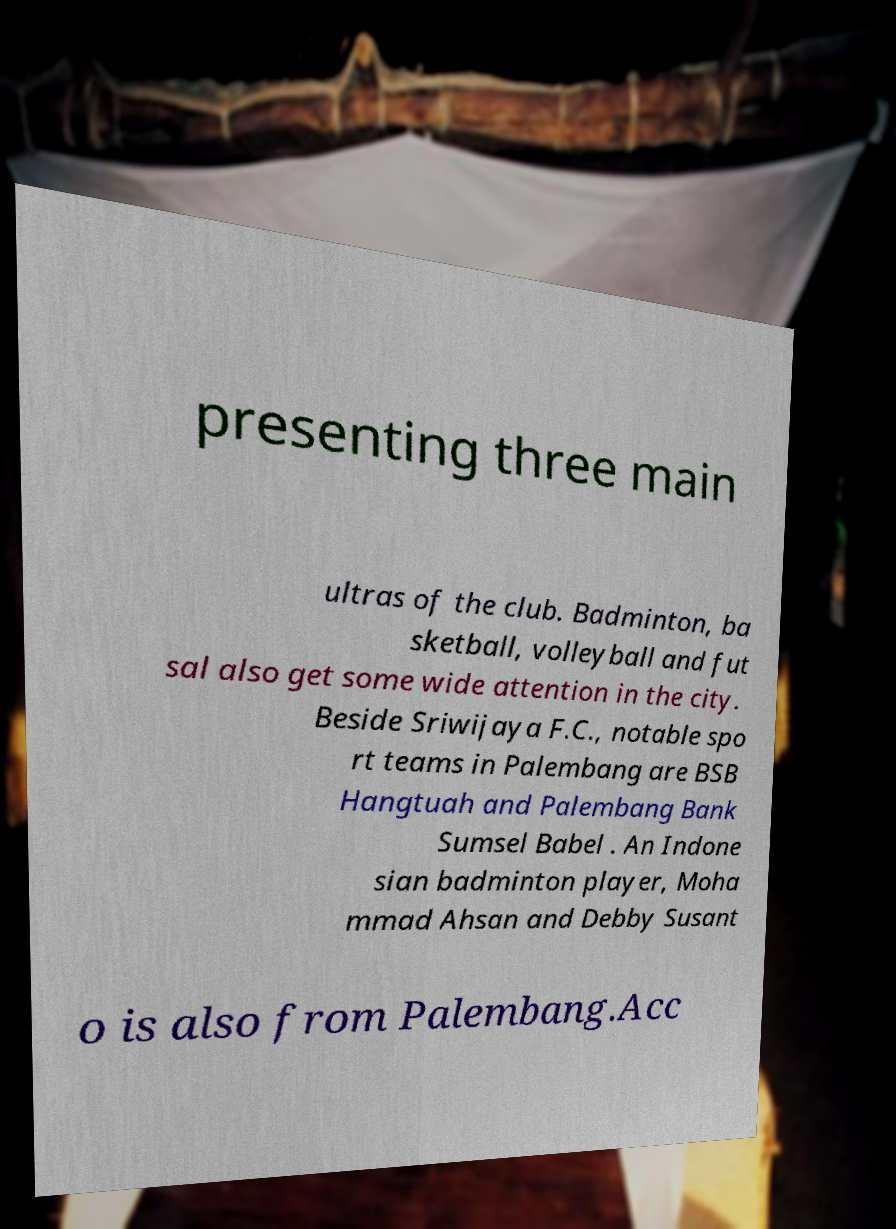Can you accurately transcribe the text from the provided image for me? presenting three main ultras of the club. Badminton, ba sketball, volleyball and fut sal also get some wide attention in the city. Beside Sriwijaya F.C., notable spo rt teams in Palembang are BSB Hangtuah and Palembang Bank Sumsel Babel . An Indone sian badminton player, Moha mmad Ahsan and Debby Susant o is also from Palembang.Acc 